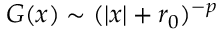Convert formula to latex. <formula><loc_0><loc_0><loc_500><loc_500>G ( x ) \sim ( | x | + r _ { 0 } ) ^ { - p }</formula> 